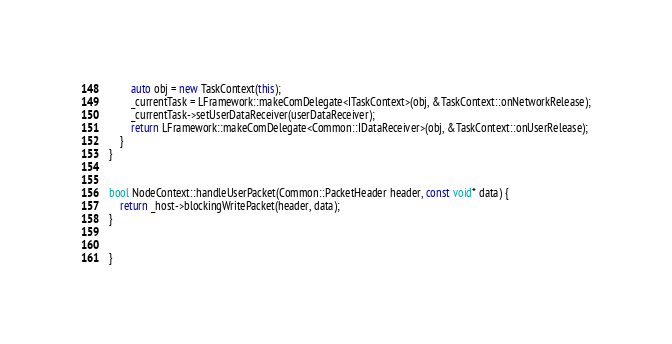Convert code to text. <code><loc_0><loc_0><loc_500><loc_500><_C++_>        auto obj = new TaskContext(this);
        _currentTask = LFramework::makeComDelegate<ITaskContext>(obj, &TaskContext::onNetworkRelease);
        _currentTask->setUserDataReceiver(userDataReceiver);
        return LFramework::makeComDelegate<Common::IDataReceiver>(obj, &TaskContext::onUserRelease);
    }
}


bool NodeContext::handleUserPacket(Common::PacketHeader header, const void* data) {
    return _host->blockingWritePacket(header, data);
}


}
</code> 